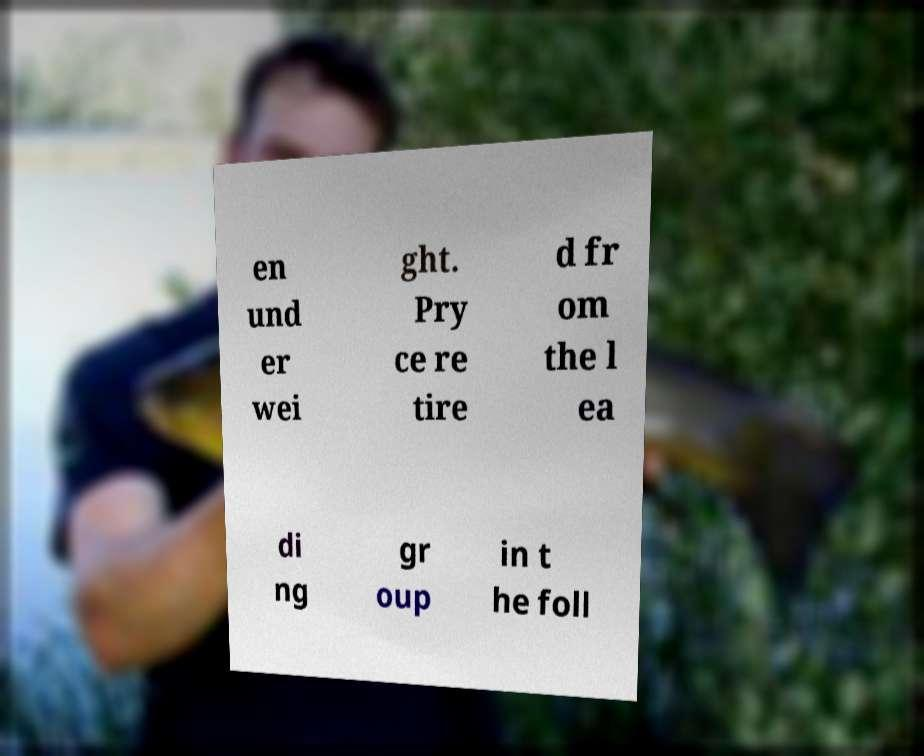Please identify and transcribe the text found in this image. en und er wei ght. Pry ce re tire d fr om the l ea di ng gr oup in t he foll 